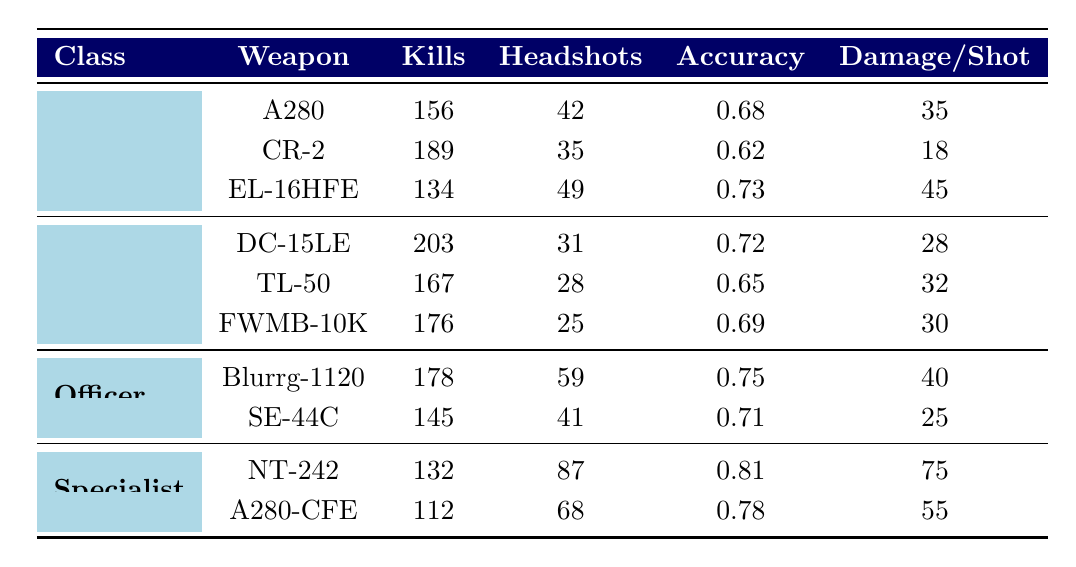What is the most effective weapon in terms of accuracy? The weapon with the highest accuracy listed in the table is NT-242 with an accuracy of 0.81.
Answer: NT-242 Which character class has the highest total kills? To find the highest total kills, we can sum the kills for each class: Assault (156+189+134=479), Heavy (203+167+176=546), Officer (178+145=323), Specialist (132+112=244). The Heavy class has the highest total kills at 546.
Answer: Heavy How many headshots did the Assault class achieve in total? The headshots in the Assault class are summed up: A280 (42) + CR-2 (35) + EL-16HFE (49) = 126 headshots in total.
Answer: 126 Is the damage per shot of the Specialist class generally higher than that of the Assault class? Comparing the average damage per shot: Specialist class (75+55)/2 = 65, Assault class (35+18+45)/3 = 32.66. The Specialist class has higher average damage per shot.
Answer: Yes What is the average accuracy of the Heavy class weapons? To calculate the average accuracy of the Heavy class, the accuracies of their weapons are added and divided by the total weapons: (0.72 + 0.65 + 0.69) / 3 = 0.6867, which can be rounded to 0.69.
Answer: 0.69 Which character class had the lowest number of kills, and what is the number of kills? The Specialist class has the lowest number of kills: NT-242 (132) + A280-CFE (112) = 244, which is lower than other classes.
Answer: Specialist, 244 Which weapon has the highest damage per shot? Among the weapons listed, NT-242 has the highest damage per shot at 75.
Answer: NT-242 Do any Officer class weapons have an accuracy below 0.70? The SE-44C has an accuracy of 0.71, and both Officer class weapons have accuracies above 0.70.
Answer: No 